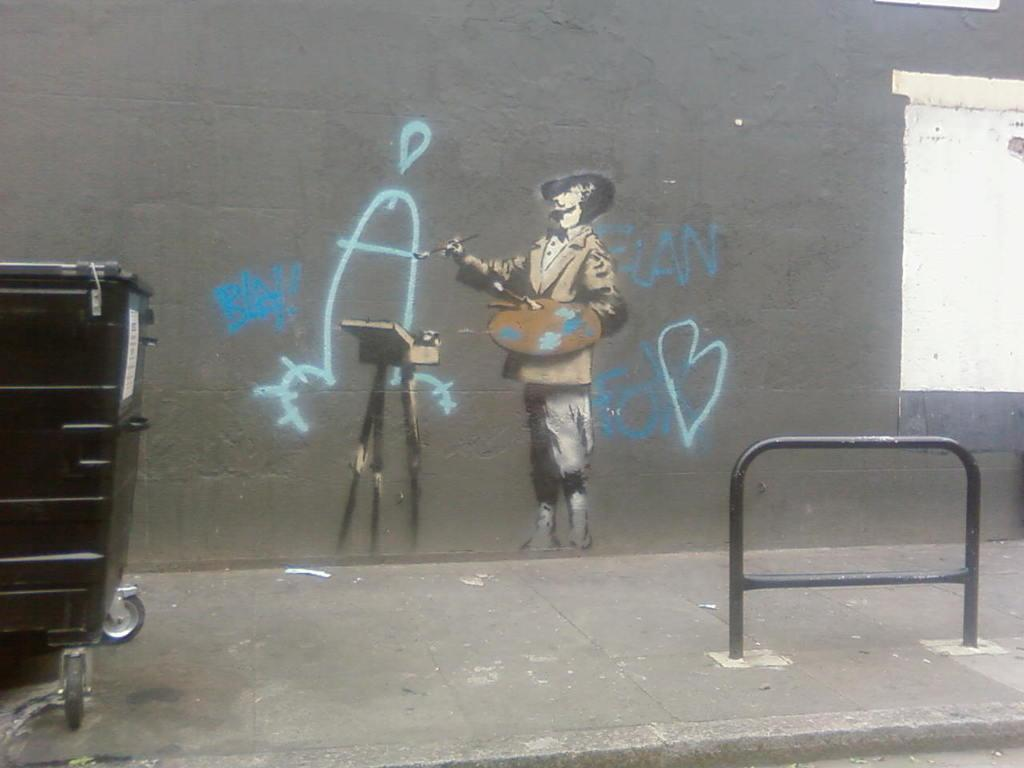What is depicted on the wall in the image? There is a painting of a man on a wall in the image. What object can be seen on the right side of the image? There is an iron stand on the right side of the image. What can be found on the left side of the image? There appears to be a dustbin on the left side of the image. What type of surface is visible at the bottom of the image? There is pavement at the bottom of the image. How many tomatoes are being carried by the man in the painting? There is no man carrying tomatoes in the painting; it is a painting of a man. Can you describe the walk of the fly in the image? There are no flies present in the image, so it is not possible to describe their walk. 